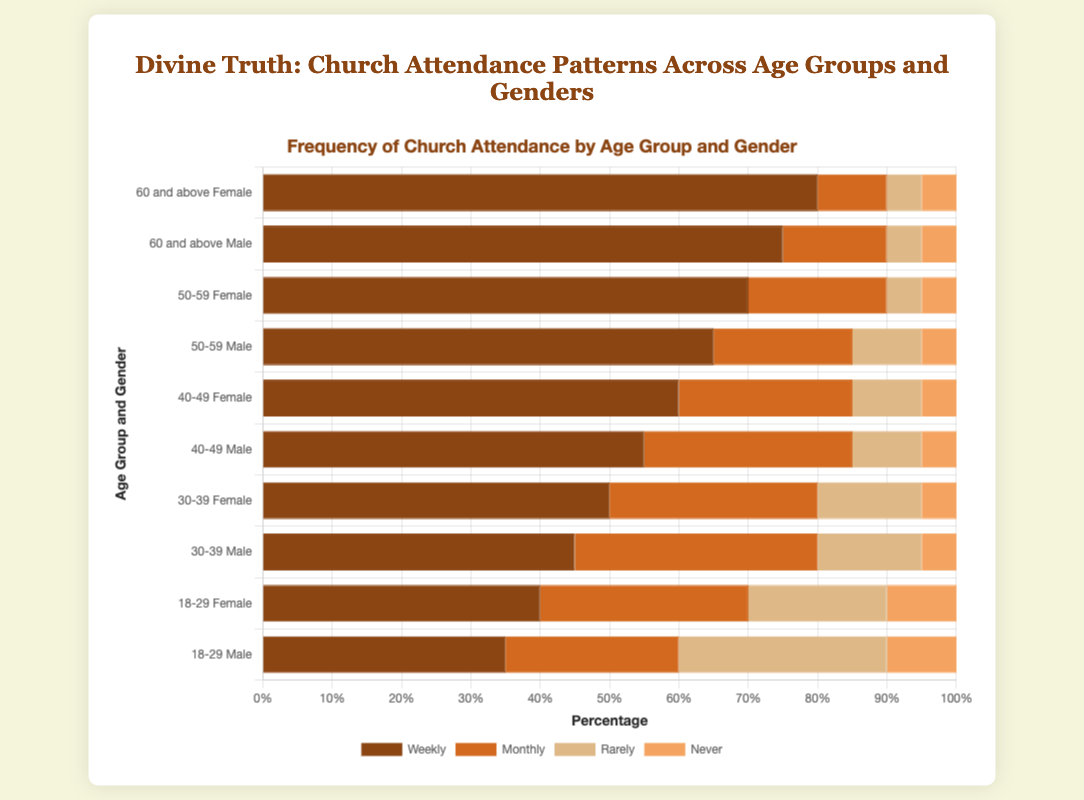Which age group and gender has the highest percentage of weekly church attendance? The '60 and above' age group for females has the highest weekly attendance. The bar for '60 and above Female' for the weekly category is the longest among all. This indicates the highest percentage.
Answer: 60 and above Female Which male age group has the highest monthly attendance? For males, the '30-39' age group has the highest monthly attendance. By comparing the heights of monthly attendance bars for males, the bar for '30-39 Male' is the longest.
Answer: 30-39 Male Among 18-29 year-olds, which gender shows a higher rate of rarely attending church? The female '18-29' group has a lower 'rarely' attendance bar compared to males. This shows that more males rarely attend church than females in this age group.
Answer: Male What is the combined percentage of individuals who either rarely or never attend church in the '50-59 Female' group? Adding the 'rarely' and 'never' bars for '50-59 Female', we get 5% (rarely) + 5% (never) = 10%.
Answer: 10% For which gender and age group is the 'monthly' attendance percentage equal to the 'never' attendance percentage? For the '18-29 Male' group, both 'monthly' and 'never' attendance percentages are the same at 10%.
Answer: 18-29 Male Compare the total percentage of individuals who never attend church between '30-39' and '40-49' age groups for both genders combined. Which age group has a higher percentage? For '30-39', total 'never' percentage: 5% (Male) + 5% (Female) = 10%. For '40-49', total 'never' percentage: 5% (Male) + 5% (Female) = 10%. Both age groups have an equal 'never' attendance.
Answer: Both are equal What’s the difference in the percentage of weekly attendance between '50-59 Male' and '40-49 Female'? 'Weekly' attendance for '50-59 Male' is 65% and for '40-49 Female' is 60%. The difference is 65% - 60% = 5%.
Answer: 5% Which age group and gender have the smallest gap between 'weekly' and 'monthly' attendance? For '18-29 Male', the weekly attendance is 35% and the monthly is 25%, giving a gap of 10%, which appears to be the smallest among all visible gaps.
Answer: 18-29 Male How does the 'rarely' attendance for '40-49 Male' compare with '60 and above Female'? 'Rarely' attendance for '40-49 Male' is 10% and for '60 and above Female' is 5%. Thus, '40-49 Male' has a higher 'rarely' attendance.
Answer: 40-49 Male 